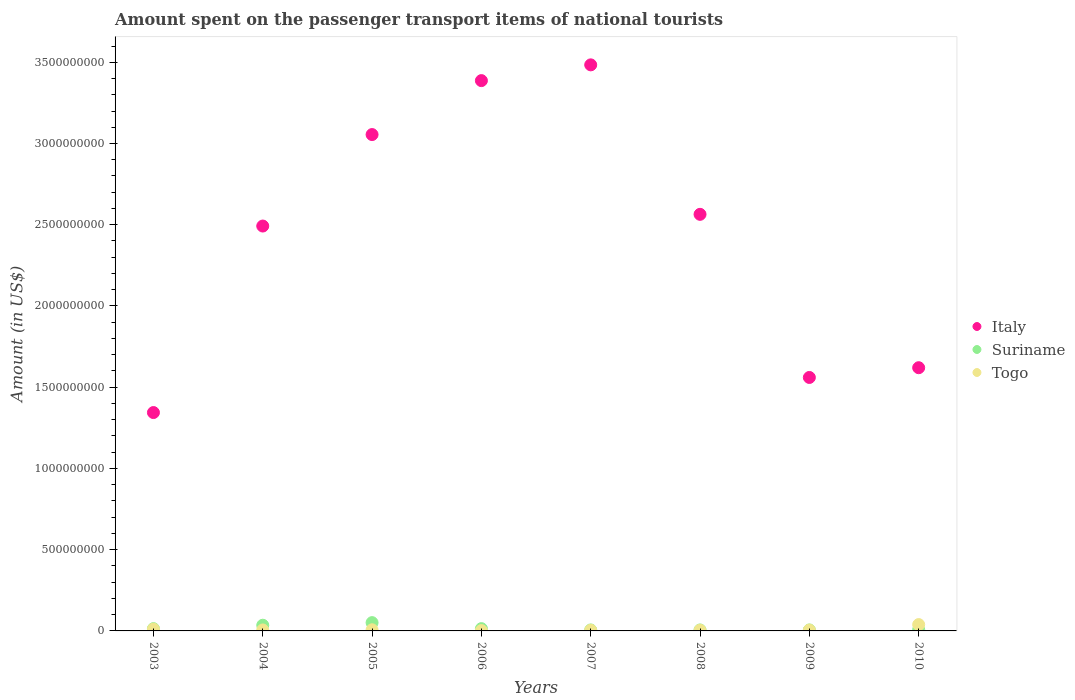How many different coloured dotlines are there?
Your answer should be compact. 3. Is the number of dotlines equal to the number of legend labels?
Ensure brevity in your answer.  Yes. What is the amount spent on the passenger transport items of national tourists in Italy in 2007?
Your answer should be very brief. 3.48e+09. Across all years, what is the maximum amount spent on the passenger transport items of national tourists in Suriname?
Offer a very short reply. 5.10e+07. Across all years, what is the minimum amount spent on the passenger transport items of national tourists in Suriname?
Provide a short and direct response. 6.00e+06. What is the total amount spent on the passenger transport items of national tourists in Suriname in the graph?
Offer a very short reply. 1.40e+08. What is the difference between the amount spent on the passenger transport items of national tourists in Togo in 2008 and that in 2010?
Your answer should be compact. -3.50e+07. What is the difference between the amount spent on the passenger transport items of national tourists in Togo in 2004 and the amount spent on the passenger transport items of national tourists in Italy in 2007?
Keep it short and to the point. -3.48e+09. What is the average amount spent on the passenger transport items of national tourists in Suriname per year?
Offer a terse response. 1.75e+07. In the year 2010, what is the difference between the amount spent on the passenger transport items of national tourists in Suriname and amount spent on the passenger transport items of national tourists in Italy?
Your answer should be very brief. -1.61e+09. What is the ratio of the amount spent on the passenger transport items of national tourists in Togo in 2005 to that in 2006?
Provide a succinct answer. 3.5. Is the amount spent on the passenger transport items of national tourists in Suriname in 2008 less than that in 2009?
Your response must be concise. No. Is the difference between the amount spent on the passenger transport items of national tourists in Suriname in 2006 and 2007 greater than the difference between the amount spent on the passenger transport items of national tourists in Italy in 2006 and 2007?
Keep it short and to the point. Yes. What is the difference between the highest and the second highest amount spent on the passenger transport items of national tourists in Suriname?
Make the answer very short. 1.60e+07. What is the difference between the highest and the lowest amount spent on the passenger transport items of national tourists in Suriname?
Your answer should be very brief. 4.50e+07. In how many years, is the amount spent on the passenger transport items of national tourists in Togo greater than the average amount spent on the passenger transport items of national tourists in Togo taken over all years?
Keep it short and to the point. 2. Is it the case that in every year, the sum of the amount spent on the passenger transport items of national tourists in Italy and amount spent on the passenger transport items of national tourists in Suriname  is greater than the amount spent on the passenger transport items of national tourists in Togo?
Keep it short and to the point. Yes. Are the values on the major ticks of Y-axis written in scientific E-notation?
Your answer should be very brief. No. Does the graph contain any zero values?
Offer a very short reply. No. Does the graph contain grids?
Provide a short and direct response. No. How many legend labels are there?
Provide a short and direct response. 3. How are the legend labels stacked?
Give a very brief answer. Vertical. What is the title of the graph?
Offer a terse response. Amount spent on the passenger transport items of national tourists. What is the label or title of the X-axis?
Your response must be concise. Years. What is the label or title of the Y-axis?
Your answer should be very brief. Amount (in US$). What is the Amount (in US$) in Italy in 2003?
Keep it short and to the point. 1.34e+09. What is the Amount (in US$) of Suriname in 2003?
Your answer should be compact. 1.40e+07. What is the Amount (in US$) of Togo in 2003?
Give a very brief answer. 1.10e+07. What is the Amount (in US$) of Italy in 2004?
Provide a succinct answer. 2.49e+09. What is the Amount (in US$) of Suriname in 2004?
Provide a succinct answer. 3.50e+07. What is the Amount (in US$) of Italy in 2005?
Your response must be concise. 3.06e+09. What is the Amount (in US$) of Suriname in 2005?
Offer a very short reply. 5.10e+07. What is the Amount (in US$) of Togo in 2005?
Ensure brevity in your answer.  7.00e+06. What is the Amount (in US$) of Italy in 2006?
Your answer should be compact. 3.39e+09. What is the Amount (in US$) in Suriname in 2006?
Your answer should be compact. 1.40e+07. What is the Amount (in US$) in Togo in 2006?
Keep it short and to the point. 2.00e+06. What is the Amount (in US$) in Italy in 2007?
Keep it short and to the point. 3.48e+09. What is the Amount (in US$) of Suriname in 2007?
Your response must be concise. 6.00e+06. What is the Amount (in US$) of Togo in 2007?
Give a very brief answer. 4.00e+06. What is the Amount (in US$) in Italy in 2008?
Offer a terse response. 2.56e+09. What is the Amount (in US$) in Italy in 2009?
Offer a terse response. 1.56e+09. What is the Amount (in US$) in Suriname in 2009?
Give a very brief answer. 6.00e+06. What is the Amount (in US$) of Togo in 2009?
Make the answer very short. 5.00e+06. What is the Amount (in US$) of Italy in 2010?
Provide a short and direct response. 1.62e+09. What is the Amount (in US$) in Suriname in 2010?
Your response must be concise. 8.00e+06. What is the Amount (in US$) in Togo in 2010?
Provide a short and direct response. 3.90e+07. Across all years, what is the maximum Amount (in US$) of Italy?
Provide a short and direct response. 3.48e+09. Across all years, what is the maximum Amount (in US$) in Suriname?
Provide a succinct answer. 5.10e+07. Across all years, what is the maximum Amount (in US$) in Togo?
Keep it short and to the point. 3.90e+07. Across all years, what is the minimum Amount (in US$) of Italy?
Your response must be concise. 1.34e+09. Across all years, what is the minimum Amount (in US$) of Togo?
Your answer should be compact. 2.00e+06. What is the total Amount (in US$) in Italy in the graph?
Offer a terse response. 1.95e+1. What is the total Amount (in US$) in Suriname in the graph?
Make the answer very short. 1.40e+08. What is the total Amount (in US$) of Togo in the graph?
Offer a very short reply. 7.80e+07. What is the difference between the Amount (in US$) of Italy in 2003 and that in 2004?
Your answer should be very brief. -1.15e+09. What is the difference between the Amount (in US$) of Suriname in 2003 and that in 2004?
Offer a very short reply. -2.10e+07. What is the difference between the Amount (in US$) of Italy in 2003 and that in 2005?
Give a very brief answer. -1.71e+09. What is the difference between the Amount (in US$) in Suriname in 2003 and that in 2005?
Provide a succinct answer. -3.70e+07. What is the difference between the Amount (in US$) of Togo in 2003 and that in 2005?
Provide a succinct answer. 4.00e+06. What is the difference between the Amount (in US$) in Italy in 2003 and that in 2006?
Your response must be concise. -2.04e+09. What is the difference between the Amount (in US$) in Togo in 2003 and that in 2006?
Provide a short and direct response. 9.00e+06. What is the difference between the Amount (in US$) of Italy in 2003 and that in 2007?
Your answer should be very brief. -2.14e+09. What is the difference between the Amount (in US$) of Suriname in 2003 and that in 2007?
Your response must be concise. 8.00e+06. What is the difference between the Amount (in US$) in Togo in 2003 and that in 2007?
Offer a very short reply. 7.00e+06. What is the difference between the Amount (in US$) of Italy in 2003 and that in 2008?
Offer a terse response. -1.22e+09. What is the difference between the Amount (in US$) of Suriname in 2003 and that in 2008?
Provide a short and direct response. 8.00e+06. What is the difference between the Amount (in US$) of Italy in 2003 and that in 2009?
Provide a short and direct response. -2.16e+08. What is the difference between the Amount (in US$) of Suriname in 2003 and that in 2009?
Provide a succinct answer. 8.00e+06. What is the difference between the Amount (in US$) in Italy in 2003 and that in 2010?
Your answer should be very brief. -2.76e+08. What is the difference between the Amount (in US$) in Togo in 2003 and that in 2010?
Ensure brevity in your answer.  -2.80e+07. What is the difference between the Amount (in US$) of Italy in 2004 and that in 2005?
Provide a succinct answer. -5.63e+08. What is the difference between the Amount (in US$) of Suriname in 2004 and that in 2005?
Your answer should be very brief. -1.60e+07. What is the difference between the Amount (in US$) of Italy in 2004 and that in 2006?
Provide a succinct answer. -8.95e+08. What is the difference between the Amount (in US$) in Suriname in 2004 and that in 2006?
Offer a very short reply. 2.10e+07. What is the difference between the Amount (in US$) of Italy in 2004 and that in 2007?
Keep it short and to the point. -9.92e+08. What is the difference between the Amount (in US$) of Suriname in 2004 and that in 2007?
Provide a short and direct response. 2.90e+07. What is the difference between the Amount (in US$) in Togo in 2004 and that in 2007?
Your response must be concise. 2.00e+06. What is the difference between the Amount (in US$) in Italy in 2004 and that in 2008?
Offer a very short reply. -7.20e+07. What is the difference between the Amount (in US$) of Suriname in 2004 and that in 2008?
Provide a short and direct response. 2.90e+07. What is the difference between the Amount (in US$) in Togo in 2004 and that in 2008?
Offer a terse response. 2.00e+06. What is the difference between the Amount (in US$) in Italy in 2004 and that in 2009?
Your answer should be compact. 9.32e+08. What is the difference between the Amount (in US$) in Suriname in 2004 and that in 2009?
Ensure brevity in your answer.  2.90e+07. What is the difference between the Amount (in US$) of Italy in 2004 and that in 2010?
Provide a short and direct response. 8.72e+08. What is the difference between the Amount (in US$) of Suriname in 2004 and that in 2010?
Keep it short and to the point. 2.70e+07. What is the difference between the Amount (in US$) of Togo in 2004 and that in 2010?
Offer a very short reply. -3.30e+07. What is the difference between the Amount (in US$) of Italy in 2005 and that in 2006?
Provide a succinct answer. -3.32e+08. What is the difference between the Amount (in US$) of Suriname in 2005 and that in 2006?
Your response must be concise. 3.70e+07. What is the difference between the Amount (in US$) of Togo in 2005 and that in 2006?
Your answer should be very brief. 5.00e+06. What is the difference between the Amount (in US$) in Italy in 2005 and that in 2007?
Make the answer very short. -4.29e+08. What is the difference between the Amount (in US$) of Suriname in 2005 and that in 2007?
Your answer should be very brief. 4.50e+07. What is the difference between the Amount (in US$) of Italy in 2005 and that in 2008?
Keep it short and to the point. 4.91e+08. What is the difference between the Amount (in US$) in Suriname in 2005 and that in 2008?
Offer a very short reply. 4.50e+07. What is the difference between the Amount (in US$) in Togo in 2005 and that in 2008?
Your answer should be very brief. 3.00e+06. What is the difference between the Amount (in US$) of Italy in 2005 and that in 2009?
Provide a succinct answer. 1.50e+09. What is the difference between the Amount (in US$) of Suriname in 2005 and that in 2009?
Ensure brevity in your answer.  4.50e+07. What is the difference between the Amount (in US$) in Italy in 2005 and that in 2010?
Offer a very short reply. 1.44e+09. What is the difference between the Amount (in US$) in Suriname in 2005 and that in 2010?
Offer a very short reply. 4.30e+07. What is the difference between the Amount (in US$) of Togo in 2005 and that in 2010?
Your response must be concise. -3.20e+07. What is the difference between the Amount (in US$) in Italy in 2006 and that in 2007?
Ensure brevity in your answer.  -9.70e+07. What is the difference between the Amount (in US$) in Suriname in 2006 and that in 2007?
Your answer should be compact. 8.00e+06. What is the difference between the Amount (in US$) in Togo in 2006 and that in 2007?
Your response must be concise. -2.00e+06. What is the difference between the Amount (in US$) in Italy in 2006 and that in 2008?
Provide a short and direct response. 8.23e+08. What is the difference between the Amount (in US$) in Suriname in 2006 and that in 2008?
Provide a short and direct response. 8.00e+06. What is the difference between the Amount (in US$) of Togo in 2006 and that in 2008?
Keep it short and to the point. -2.00e+06. What is the difference between the Amount (in US$) of Italy in 2006 and that in 2009?
Ensure brevity in your answer.  1.83e+09. What is the difference between the Amount (in US$) of Suriname in 2006 and that in 2009?
Make the answer very short. 8.00e+06. What is the difference between the Amount (in US$) in Togo in 2006 and that in 2009?
Offer a terse response. -3.00e+06. What is the difference between the Amount (in US$) in Italy in 2006 and that in 2010?
Ensure brevity in your answer.  1.77e+09. What is the difference between the Amount (in US$) in Togo in 2006 and that in 2010?
Provide a succinct answer. -3.70e+07. What is the difference between the Amount (in US$) of Italy in 2007 and that in 2008?
Ensure brevity in your answer.  9.20e+08. What is the difference between the Amount (in US$) in Suriname in 2007 and that in 2008?
Give a very brief answer. 0. What is the difference between the Amount (in US$) in Italy in 2007 and that in 2009?
Provide a succinct answer. 1.92e+09. What is the difference between the Amount (in US$) in Togo in 2007 and that in 2009?
Ensure brevity in your answer.  -1.00e+06. What is the difference between the Amount (in US$) of Italy in 2007 and that in 2010?
Your answer should be very brief. 1.86e+09. What is the difference between the Amount (in US$) in Togo in 2007 and that in 2010?
Provide a succinct answer. -3.50e+07. What is the difference between the Amount (in US$) of Italy in 2008 and that in 2009?
Make the answer very short. 1.00e+09. What is the difference between the Amount (in US$) in Italy in 2008 and that in 2010?
Provide a succinct answer. 9.44e+08. What is the difference between the Amount (in US$) of Togo in 2008 and that in 2010?
Your response must be concise. -3.50e+07. What is the difference between the Amount (in US$) in Italy in 2009 and that in 2010?
Offer a terse response. -6.00e+07. What is the difference between the Amount (in US$) in Togo in 2009 and that in 2010?
Your answer should be very brief. -3.40e+07. What is the difference between the Amount (in US$) in Italy in 2003 and the Amount (in US$) in Suriname in 2004?
Offer a terse response. 1.31e+09. What is the difference between the Amount (in US$) in Italy in 2003 and the Amount (in US$) in Togo in 2004?
Offer a very short reply. 1.34e+09. What is the difference between the Amount (in US$) of Suriname in 2003 and the Amount (in US$) of Togo in 2004?
Give a very brief answer. 8.00e+06. What is the difference between the Amount (in US$) of Italy in 2003 and the Amount (in US$) of Suriname in 2005?
Offer a terse response. 1.29e+09. What is the difference between the Amount (in US$) in Italy in 2003 and the Amount (in US$) in Togo in 2005?
Keep it short and to the point. 1.34e+09. What is the difference between the Amount (in US$) in Suriname in 2003 and the Amount (in US$) in Togo in 2005?
Offer a very short reply. 7.00e+06. What is the difference between the Amount (in US$) in Italy in 2003 and the Amount (in US$) in Suriname in 2006?
Make the answer very short. 1.33e+09. What is the difference between the Amount (in US$) in Italy in 2003 and the Amount (in US$) in Togo in 2006?
Give a very brief answer. 1.34e+09. What is the difference between the Amount (in US$) of Suriname in 2003 and the Amount (in US$) of Togo in 2006?
Give a very brief answer. 1.20e+07. What is the difference between the Amount (in US$) of Italy in 2003 and the Amount (in US$) of Suriname in 2007?
Make the answer very short. 1.34e+09. What is the difference between the Amount (in US$) in Italy in 2003 and the Amount (in US$) in Togo in 2007?
Keep it short and to the point. 1.34e+09. What is the difference between the Amount (in US$) in Italy in 2003 and the Amount (in US$) in Suriname in 2008?
Your answer should be very brief. 1.34e+09. What is the difference between the Amount (in US$) of Italy in 2003 and the Amount (in US$) of Togo in 2008?
Your answer should be very brief. 1.34e+09. What is the difference between the Amount (in US$) in Italy in 2003 and the Amount (in US$) in Suriname in 2009?
Provide a short and direct response. 1.34e+09. What is the difference between the Amount (in US$) of Italy in 2003 and the Amount (in US$) of Togo in 2009?
Keep it short and to the point. 1.34e+09. What is the difference between the Amount (in US$) of Suriname in 2003 and the Amount (in US$) of Togo in 2009?
Your response must be concise. 9.00e+06. What is the difference between the Amount (in US$) in Italy in 2003 and the Amount (in US$) in Suriname in 2010?
Ensure brevity in your answer.  1.34e+09. What is the difference between the Amount (in US$) of Italy in 2003 and the Amount (in US$) of Togo in 2010?
Your answer should be compact. 1.30e+09. What is the difference between the Amount (in US$) in Suriname in 2003 and the Amount (in US$) in Togo in 2010?
Provide a succinct answer. -2.50e+07. What is the difference between the Amount (in US$) of Italy in 2004 and the Amount (in US$) of Suriname in 2005?
Your answer should be very brief. 2.44e+09. What is the difference between the Amount (in US$) of Italy in 2004 and the Amount (in US$) of Togo in 2005?
Offer a terse response. 2.48e+09. What is the difference between the Amount (in US$) of Suriname in 2004 and the Amount (in US$) of Togo in 2005?
Offer a very short reply. 2.80e+07. What is the difference between the Amount (in US$) in Italy in 2004 and the Amount (in US$) in Suriname in 2006?
Your answer should be very brief. 2.48e+09. What is the difference between the Amount (in US$) in Italy in 2004 and the Amount (in US$) in Togo in 2006?
Your response must be concise. 2.49e+09. What is the difference between the Amount (in US$) in Suriname in 2004 and the Amount (in US$) in Togo in 2006?
Your answer should be very brief. 3.30e+07. What is the difference between the Amount (in US$) in Italy in 2004 and the Amount (in US$) in Suriname in 2007?
Your answer should be very brief. 2.49e+09. What is the difference between the Amount (in US$) of Italy in 2004 and the Amount (in US$) of Togo in 2007?
Your answer should be very brief. 2.49e+09. What is the difference between the Amount (in US$) in Suriname in 2004 and the Amount (in US$) in Togo in 2007?
Your response must be concise. 3.10e+07. What is the difference between the Amount (in US$) in Italy in 2004 and the Amount (in US$) in Suriname in 2008?
Your response must be concise. 2.49e+09. What is the difference between the Amount (in US$) in Italy in 2004 and the Amount (in US$) in Togo in 2008?
Offer a terse response. 2.49e+09. What is the difference between the Amount (in US$) of Suriname in 2004 and the Amount (in US$) of Togo in 2008?
Offer a very short reply. 3.10e+07. What is the difference between the Amount (in US$) of Italy in 2004 and the Amount (in US$) of Suriname in 2009?
Offer a very short reply. 2.49e+09. What is the difference between the Amount (in US$) in Italy in 2004 and the Amount (in US$) in Togo in 2009?
Make the answer very short. 2.49e+09. What is the difference between the Amount (in US$) in Suriname in 2004 and the Amount (in US$) in Togo in 2009?
Give a very brief answer. 3.00e+07. What is the difference between the Amount (in US$) in Italy in 2004 and the Amount (in US$) in Suriname in 2010?
Your answer should be very brief. 2.48e+09. What is the difference between the Amount (in US$) in Italy in 2004 and the Amount (in US$) in Togo in 2010?
Keep it short and to the point. 2.45e+09. What is the difference between the Amount (in US$) in Suriname in 2004 and the Amount (in US$) in Togo in 2010?
Provide a succinct answer. -4.00e+06. What is the difference between the Amount (in US$) in Italy in 2005 and the Amount (in US$) in Suriname in 2006?
Your response must be concise. 3.04e+09. What is the difference between the Amount (in US$) in Italy in 2005 and the Amount (in US$) in Togo in 2006?
Provide a succinct answer. 3.05e+09. What is the difference between the Amount (in US$) in Suriname in 2005 and the Amount (in US$) in Togo in 2006?
Your answer should be compact. 4.90e+07. What is the difference between the Amount (in US$) of Italy in 2005 and the Amount (in US$) of Suriname in 2007?
Ensure brevity in your answer.  3.05e+09. What is the difference between the Amount (in US$) of Italy in 2005 and the Amount (in US$) of Togo in 2007?
Your answer should be compact. 3.05e+09. What is the difference between the Amount (in US$) of Suriname in 2005 and the Amount (in US$) of Togo in 2007?
Your response must be concise. 4.70e+07. What is the difference between the Amount (in US$) of Italy in 2005 and the Amount (in US$) of Suriname in 2008?
Give a very brief answer. 3.05e+09. What is the difference between the Amount (in US$) of Italy in 2005 and the Amount (in US$) of Togo in 2008?
Ensure brevity in your answer.  3.05e+09. What is the difference between the Amount (in US$) of Suriname in 2005 and the Amount (in US$) of Togo in 2008?
Keep it short and to the point. 4.70e+07. What is the difference between the Amount (in US$) of Italy in 2005 and the Amount (in US$) of Suriname in 2009?
Provide a short and direct response. 3.05e+09. What is the difference between the Amount (in US$) of Italy in 2005 and the Amount (in US$) of Togo in 2009?
Provide a succinct answer. 3.05e+09. What is the difference between the Amount (in US$) of Suriname in 2005 and the Amount (in US$) of Togo in 2009?
Provide a succinct answer. 4.60e+07. What is the difference between the Amount (in US$) in Italy in 2005 and the Amount (in US$) in Suriname in 2010?
Ensure brevity in your answer.  3.05e+09. What is the difference between the Amount (in US$) in Italy in 2005 and the Amount (in US$) in Togo in 2010?
Your response must be concise. 3.02e+09. What is the difference between the Amount (in US$) of Suriname in 2005 and the Amount (in US$) of Togo in 2010?
Make the answer very short. 1.20e+07. What is the difference between the Amount (in US$) of Italy in 2006 and the Amount (in US$) of Suriname in 2007?
Give a very brief answer. 3.38e+09. What is the difference between the Amount (in US$) in Italy in 2006 and the Amount (in US$) in Togo in 2007?
Provide a succinct answer. 3.38e+09. What is the difference between the Amount (in US$) of Italy in 2006 and the Amount (in US$) of Suriname in 2008?
Your answer should be very brief. 3.38e+09. What is the difference between the Amount (in US$) in Italy in 2006 and the Amount (in US$) in Togo in 2008?
Your answer should be compact. 3.38e+09. What is the difference between the Amount (in US$) in Suriname in 2006 and the Amount (in US$) in Togo in 2008?
Provide a short and direct response. 1.00e+07. What is the difference between the Amount (in US$) in Italy in 2006 and the Amount (in US$) in Suriname in 2009?
Provide a short and direct response. 3.38e+09. What is the difference between the Amount (in US$) in Italy in 2006 and the Amount (in US$) in Togo in 2009?
Ensure brevity in your answer.  3.38e+09. What is the difference between the Amount (in US$) in Suriname in 2006 and the Amount (in US$) in Togo in 2009?
Offer a very short reply. 9.00e+06. What is the difference between the Amount (in US$) of Italy in 2006 and the Amount (in US$) of Suriname in 2010?
Your response must be concise. 3.38e+09. What is the difference between the Amount (in US$) of Italy in 2006 and the Amount (in US$) of Togo in 2010?
Offer a terse response. 3.35e+09. What is the difference between the Amount (in US$) of Suriname in 2006 and the Amount (in US$) of Togo in 2010?
Make the answer very short. -2.50e+07. What is the difference between the Amount (in US$) of Italy in 2007 and the Amount (in US$) of Suriname in 2008?
Give a very brief answer. 3.48e+09. What is the difference between the Amount (in US$) in Italy in 2007 and the Amount (in US$) in Togo in 2008?
Offer a very short reply. 3.48e+09. What is the difference between the Amount (in US$) of Italy in 2007 and the Amount (in US$) of Suriname in 2009?
Your answer should be very brief. 3.48e+09. What is the difference between the Amount (in US$) of Italy in 2007 and the Amount (in US$) of Togo in 2009?
Make the answer very short. 3.48e+09. What is the difference between the Amount (in US$) in Suriname in 2007 and the Amount (in US$) in Togo in 2009?
Provide a succinct answer. 1.00e+06. What is the difference between the Amount (in US$) in Italy in 2007 and the Amount (in US$) in Suriname in 2010?
Your answer should be compact. 3.48e+09. What is the difference between the Amount (in US$) in Italy in 2007 and the Amount (in US$) in Togo in 2010?
Give a very brief answer. 3.44e+09. What is the difference between the Amount (in US$) in Suriname in 2007 and the Amount (in US$) in Togo in 2010?
Provide a succinct answer. -3.30e+07. What is the difference between the Amount (in US$) of Italy in 2008 and the Amount (in US$) of Suriname in 2009?
Your response must be concise. 2.56e+09. What is the difference between the Amount (in US$) of Italy in 2008 and the Amount (in US$) of Togo in 2009?
Offer a very short reply. 2.56e+09. What is the difference between the Amount (in US$) of Suriname in 2008 and the Amount (in US$) of Togo in 2009?
Keep it short and to the point. 1.00e+06. What is the difference between the Amount (in US$) in Italy in 2008 and the Amount (in US$) in Suriname in 2010?
Provide a succinct answer. 2.56e+09. What is the difference between the Amount (in US$) of Italy in 2008 and the Amount (in US$) of Togo in 2010?
Give a very brief answer. 2.52e+09. What is the difference between the Amount (in US$) of Suriname in 2008 and the Amount (in US$) of Togo in 2010?
Give a very brief answer. -3.30e+07. What is the difference between the Amount (in US$) in Italy in 2009 and the Amount (in US$) in Suriname in 2010?
Your answer should be compact. 1.55e+09. What is the difference between the Amount (in US$) of Italy in 2009 and the Amount (in US$) of Togo in 2010?
Make the answer very short. 1.52e+09. What is the difference between the Amount (in US$) of Suriname in 2009 and the Amount (in US$) of Togo in 2010?
Provide a succinct answer. -3.30e+07. What is the average Amount (in US$) of Italy per year?
Keep it short and to the point. 2.44e+09. What is the average Amount (in US$) of Suriname per year?
Keep it short and to the point. 1.75e+07. What is the average Amount (in US$) in Togo per year?
Your response must be concise. 9.75e+06. In the year 2003, what is the difference between the Amount (in US$) of Italy and Amount (in US$) of Suriname?
Your answer should be compact. 1.33e+09. In the year 2003, what is the difference between the Amount (in US$) in Italy and Amount (in US$) in Togo?
Provide a short and direct response. 1.33e+09. In the year 2003, what is the difference between the Amount (in US$) in Suriname and Amount (in US$) in Togo?
Your answer should be compact. 3.00e+06. In the year 2004, what is the difference between the Amount (in US$) of Italy and Amount (in US$) of Suriname?
Provide a short and direct response. 2.46e+09. In the year 2004, what is the difference between the Amount (in US$) in Italy and Amount (in US$) in Togo?
Keep it short and to the point. 2.49e+09. In the year 2004, what is the difference between the Amount (in US$) of Suriname and Amount (in US$) of Togo?
Offer a terse response. 2.90e+07. In the year 2005, what is the difference between the Amount (in US$) in Italy and Amount (in US$) in Suriname?
Your response must be concise. 3.00e+09. In the year 2005, what is the difference between the Amount (in US$) in Italy and Amount (in US$) in Togo?
Ensure brevity in your answer.  3.05e+09. In the year 2005, what is the difference between the Amount (in US$) of Suriname and Amount (in US$) of Togo?
Your answer should be compact. 4.40e+07. In the year 2006, what is the difference between the Amount (in US$) of Italy and Amount (in US$) of Suriname?
Provide a short and direct response. 3.37e+09. In the year 2006, what is the difference between the Amount (in US$) of Italy and Amount (in US$) of Togo?
Offer a very short reply. 3.38e+09. In the year 2007, what is the difference between the Amount (in US$) in Italy and Amount (in US$) in Suriname?
Ensure brevity in your answer.  3.48e+09. In the year 2007, what is the difference between the Amount (in US$) in Italy and Amount (in US$) in Togo?
Your answer should be compact. 3.48e+09. In the year 2008, what is the difference between the Amount (in US$) in Italy and Amount (in US$) in Suriname?
Provide a succinct answer. 2.56e+09. In the year 2008, what is the difference between the Amount (in US$) of Italy and Amount (in US$) of Togo?
Offer a very short reply. 2.56e+09. In the year 2008, what is the difference between the Amount (in US$) in Suriname and Amount (in US$) in Togo?
Ensure brevity in your answer.  2.00e+06. In the year 2009, what is the difference between the Amount (in US$) in Italy and Amount (in US$) in Suriname?
Your answer should be very brief. 1.55e+09. In the year 2009, what is the difference between the Amount (in US$) in Italy and Amount (in US$) in Togo?
Your answer should be compact. 1.56e+09. In the year 2009, what is the difference between the Amount (in US$) in Suriname and Amount (in US$) in Togo?
Keep it short and to the point. 1.00e+06. In the year 2010, what is the difference between the Amount (in US$) in Italy and Amount (in US$) in Suriname?
Keep it short and to the point. 1.61e+09. In the year 2010, what is the difference between the Amount (in US$) of Italy and Amount (in US$) of Togo?
Make the answer very short. 1.58e+09. In the year 2010, what is the difference between the Amount (in US$) in Suriname and Amount (in US$) in Togo?
Offer a terse response. -3.10e+07. What is the ratio of the Amount (in US$) in Italy in 2003 to that in 2004?
Offer a very short reply. 0.54. What is the ratio of the Amount (in US$) in Suriname in 2003 to that in 2004?
Offer a very short reply. 0.4. What is the ratio of the Amount (in US$) in Togo in 2003 to that in 2004?
Keep it short and to the point. 1.83. What is the ratio of the Amount (in US$) of Italy in 2003 to that in 2005?
Ensure brevity in your answer.  0.44. What is the ratio of the Amount (in US$) of Suriname in 2003 to that in 2005?
Your answer should be very brief. 0.27. What is the ratio of the Amount (in US$) of Togo in 2003 to that in 2005?
Make the answer very short. 1.57. What is the ratio of the Amount (in US$) of Italy in 2003 to that in 2006?
Your answer should be compact. 0.4. What is the ratio of the Amount (in US$) of Suriname in 2003 to that in 2006?
Make the answer very short. 1. What is the ratio of the Amount (in US$) of Togo in 2003 to that in 2006?
Offer a very short reply. 5.5. What is the ratio of the Amount (in US$) in Italy in 2003 to that in 2007?
Your answer should be very brief. 0.39. What is the ratio of the Amount (in US$) of Suriname in 2003 to that in 2007?
Offer a terse response. 2.33. What is the ratio of the Amount (in US$) in Togo in 2003 to that in 2007?
Offer a terse response. 2.75. What is the ratio of the Amount (in US$) of Italy in 2003 to that in 2008?
Your answer should be very brief. 0.52. What is the ratio of the Amount (in US$) in Suriname in 2003 to that in 2008?
Your answer should be compact. 2.33. What is the ratio of the Amount (in US$) of Togo in 2003 to that in 2008?
Offer a very short reply. 2.75. What is the ratio of the Amount (in US$) of Italy in 2003 to that in 2009?
Make the answer very short. 0.86. What is the ratio of the Amount (in US$) of Suriname in 2003 to that in 2009?
Your answer should be compact. 2.33. What is the ratio of the Amount (in US$) of Italy in 2003 to that in 2010?
Make the answer very short. 0.83. What is the ratio of the Amount (in US$) of Togo in 2003 to that in 2010?
Keep it short and to the point. 0.28. What is the ratio of the Amount (in US$) of Italy in 2004 to that in 2005?
Ensure brevity in your answer.  0.82. What is the ratio of the Amount (in US$) of Suriname in 2004 to that in 2005?
Keep it short and to the point. 0.69. What is the ratio of the Amount (in US$) in Italy in 2004 to that in 2006?
Ensure brevity in your answer.  0.74. What is the ratio of the Amount (in US$) in Suriname in 2004 to that in 2006?
Your answer should be very brief. 2.5. What is the ratio of the Amount (in US$) of Togo in 2004 to that in 2006?
Provide a short and direct response. 3. What is the ratio of the Amount (in US$) of Italy in 2004 to that in 2007?
Provide a short and direct response. 0.72. What is the ratio of the Amount (in US$) in Suriname in 2004 to that in 2007?
Keep it short and to the point. 5.83. What is the ratio of the Amount (in US$) of Italy in 2004 to that in 2008?
Make the answer very short. 0.97. What is the ratio of the Amount (in US$) in Suriname in 2004 to that in 2008?
Give a very brief answer. 5.83. What is the ratio of the Amount (in US$) of Italy in 2004 to that in 2009?
Provide a succinct answer. 1.6. What is the ratio of the Amount (in US$) of Suriname in 2004 to that in 2009?
Offer a very short reply. 5.83. What is the ratio of the Amount (in US$) of Togo in 2004 to that in 2009?
Your answer should be compact. 1.2. What is the ratio of the Amount (in US$) in Italy in 2004 to that in 2010?
Provide a succinct answer. 1.54. What is the ratio of the Amount (in US$) in Suriname in 2004 to that in 2010?
Provide a succinct answer. 4.38. What is the ratio of the Amount (in US$) of Togo in 2004 to that in 2010?
Your answer should be compact. 0.15. What is the ratio of the Amount (in US$) in Italy in 2005 to that in 2006?
Offer a very short reply. 0.9. What is the ratio of the Amount (in US$) of Suriname in 2005 to that in 2006?
Give a very brief answer. 3.64. What is the ratio of the Amount (in US$) of Togo in 2005 to that in 2006?
Provide a succinct answer. 3.5. What is the ratio of the Amount (in US$) of Italy in 2005 to that in 2007?
Ensure brevity in your answer.  0.88. What is the ratio of the Amount (in US$) in Suriname in 2005 to that in 2007?
Offer a terse response. 8.5. What is the ratio of the Amount (in US$) of Italy in 2005 to that in 2008?
Make the answer very short. 1.19. What is the ratio of the Amount (in US$) in Italy in 2005 to that in 2009?
Keep it short and to the point. 1.96. What is the ratio of the Amount (in US$) in Suriname in 2005 to that in 2009?
Make the answer very short. 8.5. What is the ratio of the Amount (in US$) of Togo in 2005 to that in 2009?
Keep it short and to the point. 1.4. What is the ratio of the Amount (in US$) of Italy in 2005 to that in 2010?
Make the answer very short. 1.89. What is the ratio of the Amount (in US$) of Suriname in 2005 to that in 2010?
Provide a short and direct response. 6.38. What is the ratio of the Amount (in US$) of Togo in 2005 to that in 2010?
Your response must be concise. 0.18. What is the ratio of the Amount (in US$) of Italy in 2006 to that in 2007?
Make the answer very short. 0.97. What is the ratio of the Amount (in US$) in Suriname in 2006 to that in 2007?
Ensure brevity in your answer.  2.33. What is the ratio of the Amount (in US$) in Togo in 2006 to that in 2007?
Offer a very short reply. 0.5. What is the ratio of the Amount (in US$) in Italy in 2006 to that in 2008?
Provide a short and direct response. 1.32. What is the ratio of the Amount (in US$) of Suriname in 2006 to that in 2008?
Make the answer very short. 2.33. What is the ratio of the Amount (in US$) in Togo in 2006 to that in 2008?
Offer a very short reply. 0.5. What is the ratio of the Amount (in US$) in Italy in 2006 to that in 2009?
Provide a short and direct response. 2.17. What is the ratio of the Amount (in US$) in Suriname in 2006 to that in 2009?
Your answer should be compact. 2.33. What is the ratio of the Amount (in US$) in Togo in 2006 to that in 2009?
Provide a succinct answer. 0.4. What is the ratio of the Amount (in US$) of Italy in 2006 to that in 2010?
Keep it short and to the point. 2.09. What is the ratio of the Amount (in US$) of Togo in 2006 to that in 2010?
Give a very brief answer. 0.05. What is the ratio of the Amount (in US$) in Italy in 2007 to that in 2008?
Offer a terse response. 1.36. What is the ratio of the Amount (in US$) of Togo in 2007 to that in 2008?
Give a very brief answer. 1. What is the ratio of the Amount (in US$) in Italy in 2007 to that in 2009?
Your response must be concise. 2.23. What is the ratio of the Amount (in US$) of Italy in 2007 to that in 2010?
Ensure brevity in your answer.  2.15. What is the ratio of the Amount (in US$) of Togo in 2007 to that in 2010?
Your response must be concise. 0.1. What is the ratio of the Amount (in US$) of Italy in 2008 to that in 2009?
Your response must be concise. 1.64. What is the ratio of the Amount (in US$) of Suriname in 2008 to that in 2009?
Your response must be concise. 1. What is the ratio of the Amount (in US$) of Togo in 2008 to that in 2009?
Your answer should be very brief. 0.8. What is the ratio of the Amount (in US$) in Italy in 2008 to that in 2010?
Give a very brief answer. 1.58. What is the ratio of the Amount (in US$) in Togo in 2008 to that in 2010?
Make the answer very short. 0.1. What is the ratio of the Amount (in US$) in Italy in 2009 to that in 2010?
Your answer should be very brief. 0.96. What is the ratio of the Amount (in US$) in Togo in 2009 to that in 2010?
Offer a terse response. 0.13. What is the difference between the highest and the second highest Amount (in US$) in Italy?
Offer a very short reply. 9.70e+07. What is the difference between the highest and the second highest Amount (in US$) in Suriname?
Provide a succinct answer. 1.60e+07. What is the difference between the highest and the second highest Amount (in US$) in Togo?
Ensure brevity in your answer.  2.80e+07. What is the difference between the highest and the lowest Amount (in US$) in Italy?
Your answer should be very brief. 2.14e+09. What is the difference between the highest and the lowest Amount (in US$) in Suriname?
Your answer should be compact. 4.50e+07. What is the difference between the highest and the lowest Amount (in US$) of Togo?
Keep it short and to the point. 3.70e+07. 